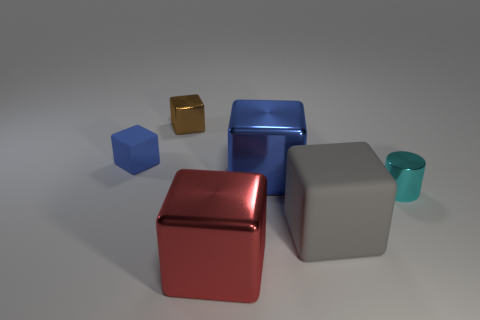Is there any other thing that is the same shape as the small cyan object?
Your answer should be very brief. No. Is there a large metal thing of the same color as the small rubber block?
Make the answer very short. Yes. What is the shape of the red metal object that is the same size as the gray rubber cube?
Offer a very short reply. Cube. Is the number of cyan things less than the number of large objects?
Provide a succinct answer. Yes. How many cyan shiny spheres are the same size as the blue matte thing?
Offer a terse response. 0. What material is the small blue object?
Make the answer very short. Rubber. What is the size of the thing to the right of the large gray cube?
Offer a very short reply. Small. What number of brown metallic objects have the same shape as the cyan metal object?
Make the answer very short. 0. What is the shape of the red thing that is made of the same material as the small cyan cylinder?
Give a very brief answer. Cube. What number of green things are either shiny things or large cubes?
Provide a succinct answer. 0. 